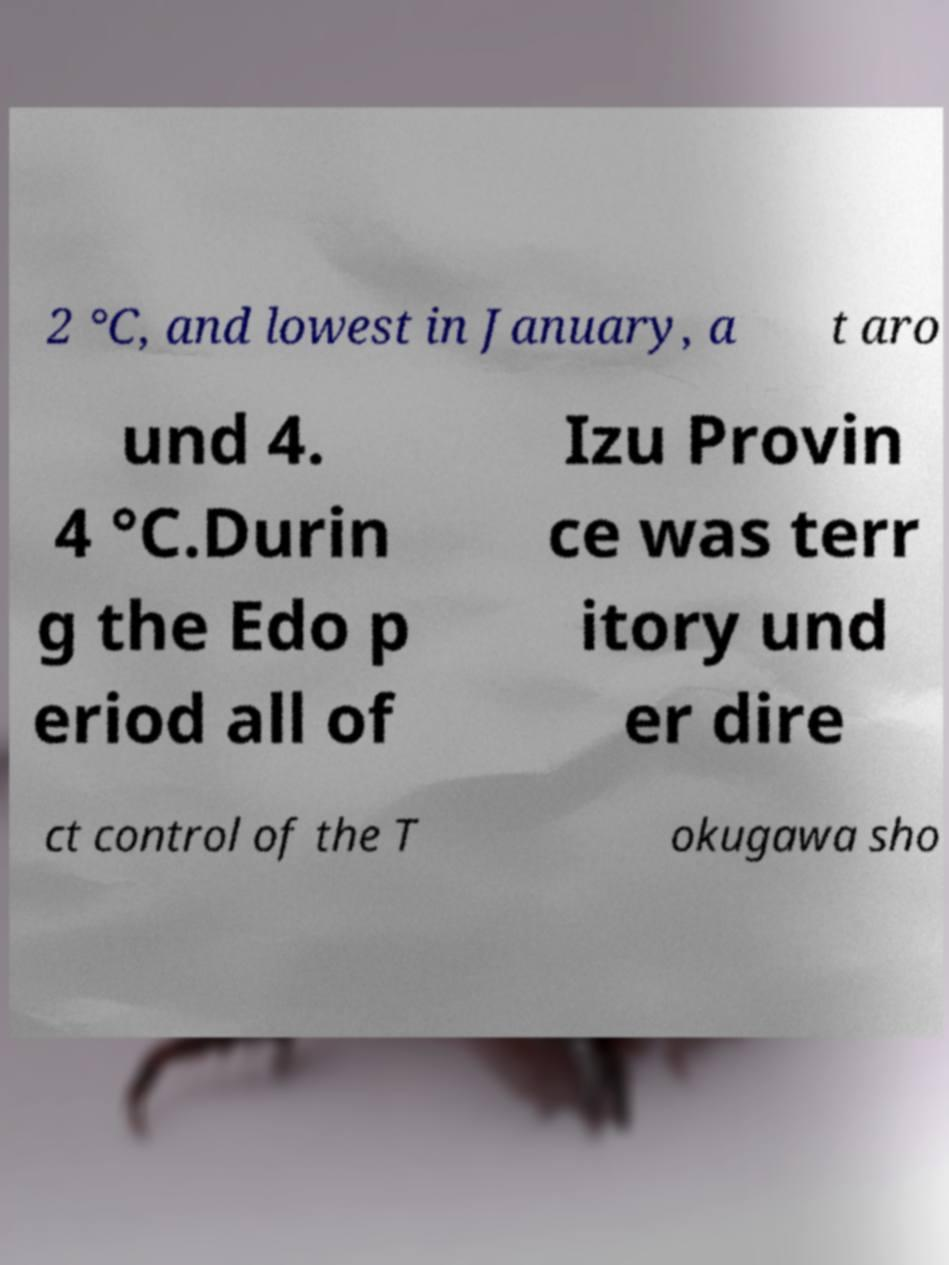For documentation purposes, I need the text within this image transcribed. Could you provide that? 2 °C, and lowest in January, a t aro und 4. 4 °C.Durin g the Edo p eriod all of Izu Provin ce was terr itory und er dire ct control of the T okugawa sho 